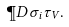<formula> <loc_0><loc_0><loc_500><loc_500>\P D { \sigma _ { i } } { \tau _ { V } } .</formula> 